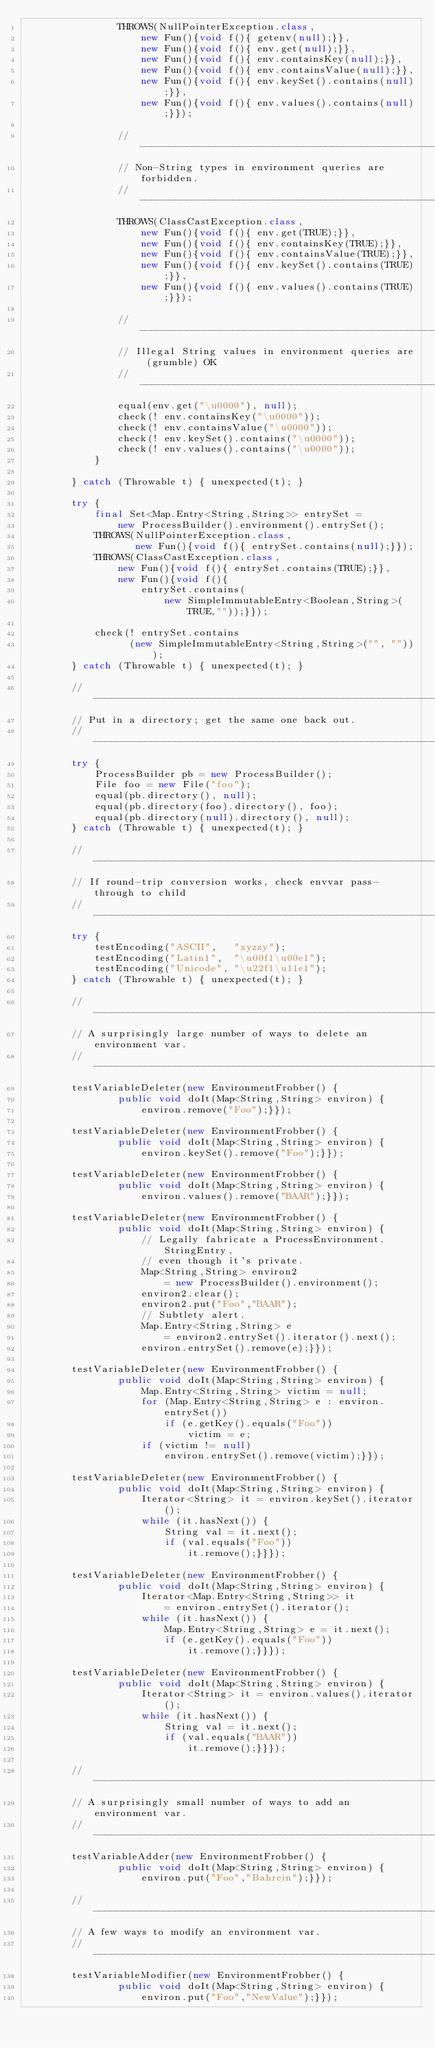Convert code to text. <code><loc_0><loc_0><loc_500><loc_500><_Java_>                THROWS(NullPointerException.class,
                    new Fun(){void f(){ getenv(null);}},
                    new Fun(){void f(){ env.get(null);}},
                    new Fun(){void f(){ env.containsKey(null);}},
                    new Fun(){void f(){ env.containsValue(null);}},
                    new Fun(){void f(){ env.keySet().contains(null);}},
                    new Fun(){void f(){ env.values().contains(null);}});

                //----------------------------------------------------------------
                // Non-String types in environment queries are forbidden.
                //----------------------------------------------------------------
                THROWS(ClassCastException.class,
                    new Fun(){void f(){ env.get(TRUE);}},
                    new Fun(){void f(){ env.containsKey(TRUE);}},
                    new Fun(){void f(){ env.containsValue(TRUE);}},
                    new Fun(){void f(){ env.keySet().contains(TRUE);}},
                    new Fun(){void f(){ env.values().contains(TRUE);}});

                //----------------------------------------------------------------
                // Illegal String values in environment queries are (grumble) OK
                //----------------------------------------------------------------
                equal(env.get("\u0000"), null);
                check(! env.containsKey("\u0000"));
                check(! env.containsValue("\u0000"));
                check(! env.keySet().contains("\u0000"));
                check(! env.values().contains("\u0000"));
            }

        } catch (Throwable t) { unexpected(t); }

        try {
            final Set<Map.Entry<String,String>> entrySet =
                new ProcessBuilder().environment().entrySet();
            THROWS(NullPointerException.class,
                   new Fun(){void f(){ entrySet.contains(null);}});
            THROWS(ClassCastException.class,
                new Fun(){void f(){ entrySet.contains(TRUE);}},
                new Fun(){void f(){
                    entrySet.contains(
                        new SimpleImmutableEntry<Boolean,String>(TRUE,""));}});

            check(! entrySet.contains
                  (new SimpleImmutableEntry<String,String>("", "")));
        } catch (Throwable t) { unexpected(t); }

        //----------------------------------------------------------------
        // Put in a directory; get the same one back out.
        //----------------------------------------------------------------
        try {
            ProcessBuilder pb = new ProcessBuilder();
            File foo = new File("foo");
            equal(pb.directory(), null);
            equal(pb.directory(foo).directory(), foo);
            equal(pb.directory(null).directory(), null);
        } catch (Throwable t) { unexpected(t); }

        //----------------------------------------------------------------
        // If round-trip conversion works, check envvar pass-through to child
        //----------------------------------------------------------------
        try {
            testEncoding("ASCII",   "xyzzy");
            testEncoding("Latin1",  "\u00f1\u00e1");
            testEncoding("Unicode", "\u22f1\u11e1");
        } catch (Throwable t) { unexpected(t); }

        //----------------------------------------------------------------
        // A surprisingly large number of ways to delete an environment var.
        //----------------------------------------------------------------
        testVariableDeleter(new EnvironmentFrobber() {
                public void doIt(Map<String,String> environ) {
                    environ.remove("Foo");}});

        testVariableDeleter(new EnvironmentFrobber() {
                public void doIt(Map<String,String> environ) {
                    environ.keySet().remove("Foo");}});

        testVariableDeleter(new EnvironmentFrobber() {
                public void doIt(Map<String,String> environ) {
                    environ.values().remove("BAAR");}});

        testVariableDeleter(new EnvironmentFrobber() {
                public void doIt(Map<String,String> environ) {
                    // Legally fabricate a ProcessEnvironment.StringEntry,
                    // even though it's private.
                    Map<String,String> environ2
                        = new ProcessBuilder().environment();
                    environ2.clear();
                    environ2.put("Foo","BAAR");
                    // Subtlety alert.
                    Map.Entry<String,String> e
                        = environ2.entrySet().iterator().next();
                    environ.entrySet().remove(e);}});

        testVariableDeleter(new EnvironmentFrobber() {
                public void doIt(Map<String,String> environ) {
                    Map.Entry<String,String> victim = null;
                    for (Map.Entry<String,String> e : environ.entrySet())
                        if (e.getKey().equals("Foo"))
                            victim = e;
                    if (victim != null)
                        environ.entrySet().remove(victim);}});

        testVariableDeleter(new EnvironmentFrobber() {
                public void doIt(Map<String,String> environ) {
                    Iterator<String> it = environ.keySet().iterator();
                    while (it.hasNext()) {
                        String val = it.next();
                        if (val.equals("Foo"))
                            it.remove();}}});

        testVariableDeleter(new EnvironmentFrobber() {
                public void doIt(Map<String,String> environ) {
                    Iterator<Map.Entry<String,String>> it
                        = environ.entrySet().iterator();
                    while (it.hasNext()) {
                        Map.Entry<String,String> e = it.next();
                        if (e.getKey().equals("Foo"))
                            it.remove();}}});

        testVariableDeleter(new EnvironmentFrobber() {
                public void doIt(Map<String,String> environ) {
                    Iterator<String> it = environ.values().iterator();
                    while (it.hasNext()) {
                        String val = it.next();
                        if (val.equals("BAAR"))
                            it.remove();}}});

        //----------------------------------------------------------------
        // A surprisingly small number of ways to add an environment var.
        //----------------------------------------------------------------
        testVariableAdder(new EnvironmentFrobber() {
                public void doIt(Map<String,String> environ) {
                    environ.put("Foo","Bahrein");}});

        //----------------------------------------------------------------
        // A few ways to modify an environment var.
        //----------------------------------------------------------------
        testVariableModifier(new EnvironmentFrobber() {
                public void doIt(Map<String,String> environ) {
                    environ.put("Foo","NewValue");}});
</code> 